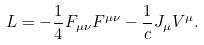<formula> <loc_0><loc_0><loc_500><loc_500>L = - \frac { 1 } { 4 } F _ { \mu \nu } F ^ { \mu \nu } - \frac { 1 } { c } J _ { \mu } V ^ { \mu } .</formula> 